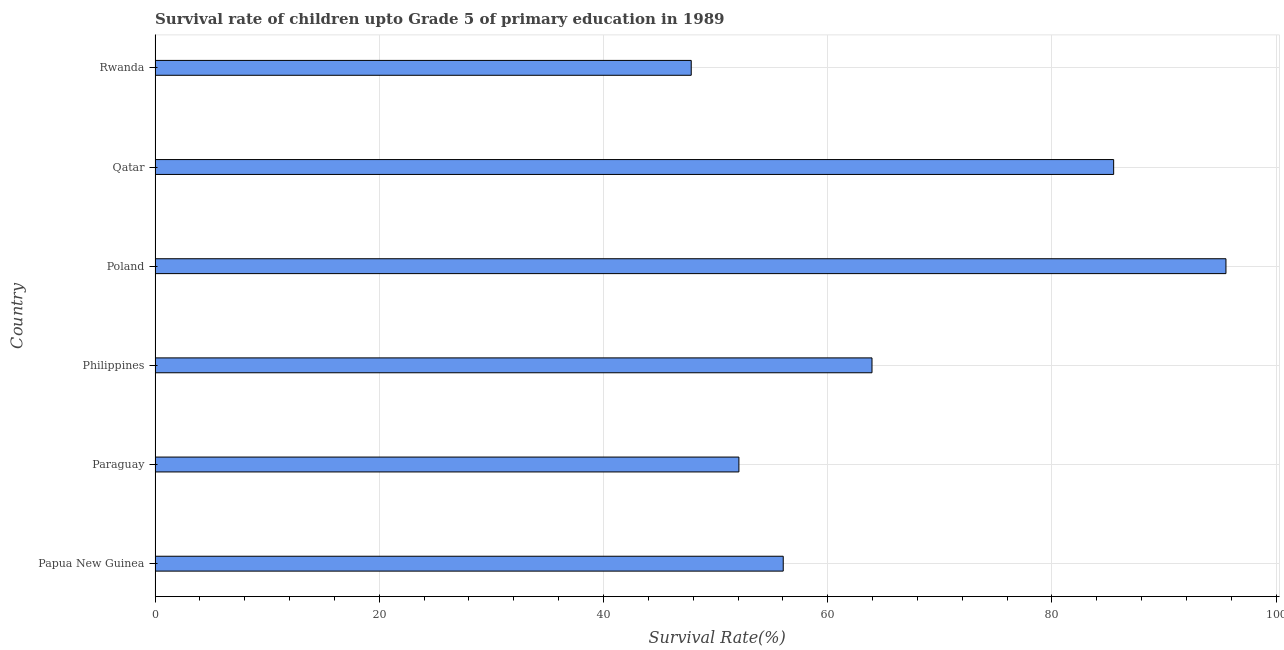Does the graph contain any zero values?
Your response must be concise. No. What is the title of the graph?
Provide a succinct answer. Survival rate of children upto Grade 5 of primary education in 1989 . What is the label or title of the X-axis?
Provide a short and direct response. Survival Rate(%). What is the label or title of the Y-axis?
Offer a terse response. Country. What is the survival rate in Papua New Guinea?
Provide a succinct answer. 56.03. Across all countries, what is the maximum survival rate?
Make the answer very short. 95.52. Across all countries, what is the minimum survival rate?
Offer a very short reply. 47.83. In which country was the survival rate minimum?
Ensure brevity in your answer.  Rwanda. What is the sum of the survival rate?
Your response must be concise. 400.92. What is the difference between the survival rate in Papua New Guinea and Poland?
Your answer should be compact. -39.49. What is the average survival rate per country?
Give a very brief answer. 66.82. What is the median survival rate?
Provide a succinct answer. 59.99. What is the ratio of the survival rate in Papua New Guinea to that in Paraguay?
Provide a succinct answer. 1.08. What is the difference between the highest and the second highest survival rate?
Provide a succinct answer. 10.02. Is the sum of the survival rate in Paraguay and Poland greater than the maximum survival rate across all countries?
Offer a very short reply. Yes. What is the difference between the highest and the lowest survival rate?
Give a very brief answer. 47.7. How many bars are there?
Provide a short and direct response. 6. Are all the bars in the graph horizontal?
Offer a terse response. Yes. Are the values on the major ticks of X-axis written in scientific E-notation?
Provide a succinct answer. No. What is the Survival Rate(%) of Papua New Guinea?
Provide a succinct answer. 56.03. What is the Survival Rate(%) of Paraguay?
Keep it short and to the point. 52.08. What is the Survival Rate(%) in Philippines?
Keep it short and to the point. 63.95. What is the Survival Rate(%) in Poland?
Make the answer very short. 95.52. What is the Survival Rate(%) in Qatar?
Make the answer very short. 85.51. What is the Survival Rate(%) in Rwanda?
Offer a terse response. 47.83. What is the difference between the Survival Rate(%) in Papua New Guinea and Paraguay?
Offer a terse response. 3.95. What is the difference between the Survival Rate(%) in Papua New Guinea and Philippines?
Give a very brief answer. -7.92. What is the difference between the Survival Rate(%) in Papua New Guinea and Poland?
Your answer should be very brief. -39.49. What is the difference between the Survival Rate(%) in Papua New Guinea and Qatar?
Make the answer very short. -29.47. What is the difference between the Survival Rate(%) in Papua New Guinea and Rwanda?
Keep it short and to the point. 8.21. What is the difference between the Survival Rate(%) in Paraguay and Philippines?
Provide a short and direct response. -11.87. What is the difference between the Survival Rate(%) in Paraguay and Poland?
Keep it short and to the point. -43.44. What is the difference between the Survival Rate(%) in Paraguay and Qatar?
Your response must be concise. -33.43. What is the difference between the Survival Rate(%) in Paraguay and Rwanda?
Your response must be concise. 4.25. What is the difference between the Survival Rate(%) in Philippines and Poland?
Make the answer very short. -31.57. What is the difference between the Survival Rate(%) in Philippines and Qatar?
Give a very brief answer. -21.56. What is the difference between the Survival Rate(%) in Philippines and Rwanda?
Ensure brevity in your answer.  16.12. What is the difference between the Survival Rate(%) in Poland and Qatar?
Give a very brief answer. 10.02. What is the difference between the Survival Rate(%) in Poland and Rwanda?
Offer a terse response. 47.7. What is the difference between the Survival Rate(%) in Qatar and Rwanda?
Keep it short and to the point. 37.68. What is the ratio of the Survival Rate(%) in Papua New Guinea to that in Paraguay?
Your answer should be very brief. 1.08. What is the ratio of the Survival Rate(%) in Papua New Guinea to that in Philippines?
Keep it short and to the point. 0.88. What is the ratio of the Survival Rate(%) in Papua New Guinea to that in Poland?
Offer a very short reply. 0.59. What is the ratio of the Survival Rate(%) in Papua New Guinea to that in Qatar?
Offer a terse response. 0.66. What is the ratio of the Survival Rate(%) in Papua New Guinea to that in Rwanda?
Keep it short and to the point. 1.17. What is the ratio of the Survival Rate(%) in Paraguay to that in Philippines?
Provide a short and direct response. 0.81. What is the ratio of the Survival Rate(%) in Paraguay to that in Poland?
Offer a very short reply. 0.55. What is the ratio of the Survival Rate(%) in Paraguay to that in Qatar?
Provide a short and direct response. 0.61. What is the ratio of the Survival Rate(%) in Paraguay to that in Rwanda?
Offer a terse response. 1.09. What is the ratio of the Survival Rate(%) in Philippines to that in Poland?
Your answer should be very brief. 0.67. What is the ratio of the Survival Rate(%) in Philippines to that in Qatar?
Make the answer very short. 0.75. What is the ratio of the Survival Rate(%) in Philippines to that in Rwanda?
Offer a very short reply. 1.34. What is the ratio of the Survival Rate(%) in Poland to that in Qatar?
Keep it short and to the point. 1.12. What is the ratio of the Survival Rate(%) in Poland to that in Rwanda?
Make the answer very short. 2. What is the ratio of the Survival Rate(%) in Qatar to that in Rwanda?
Keep it short and to the point. 1.79. 